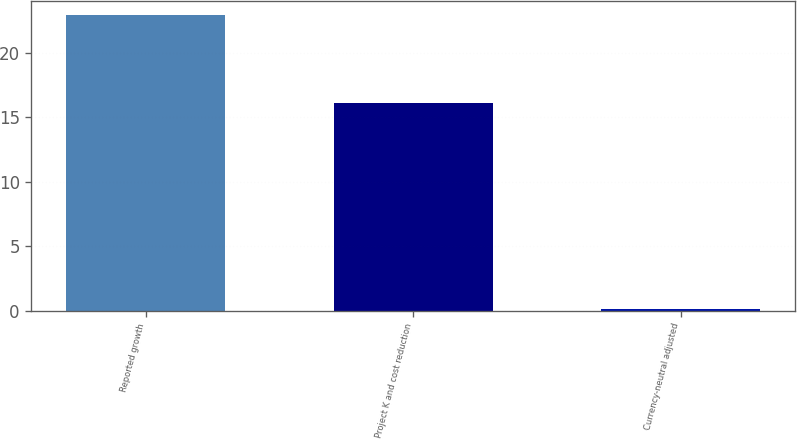<chart> <loc_0><loc_0><loc_500><loc_500><bar_chart><fcel>Reported growth<fcel>Project K and cost reduction<fcel>Currency-neutral adjusted<nl><fcel>22.9<fcel>16.1<fcel>0.1<nl></chart> 